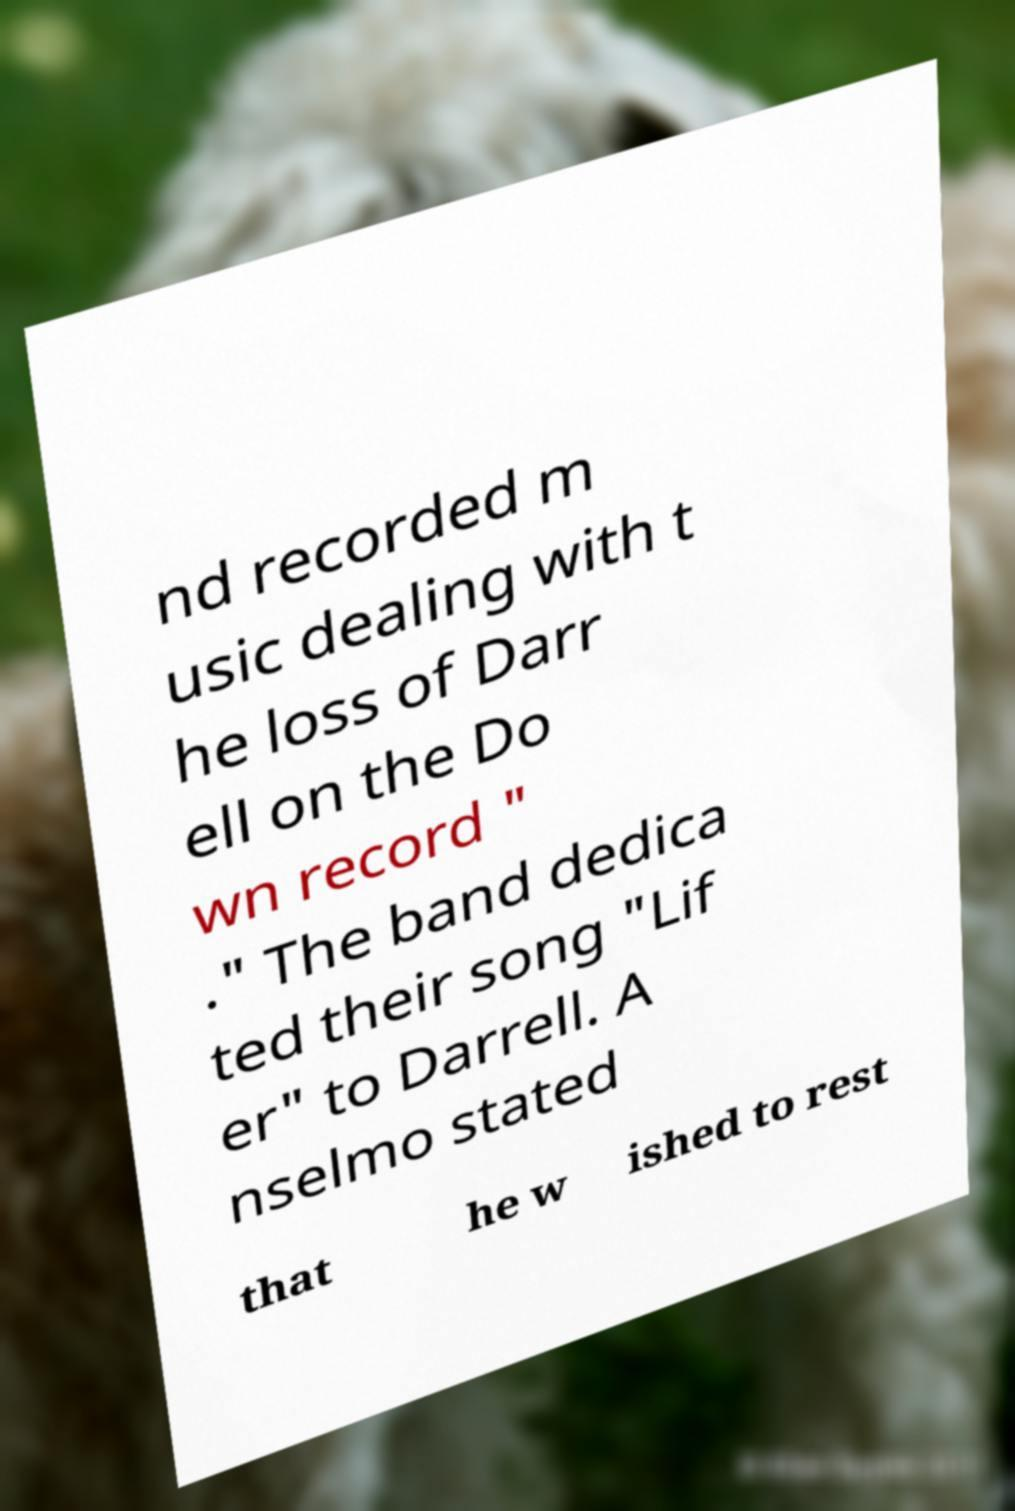There's text embedded in this image that I need extracted. Can you transcribe it verbatim? nd recorded m usic dealing with t he loss of Darr ell on the Do wn record " ." The band dedica ted their song "Lif er" to Darrell. A nselmo stated that he w ished to rest 